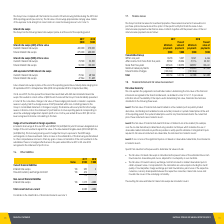According to National Storage Reit's financial document, What is the range of maturity dates of Future interest rate swaps in 2018? 24 September 2018 to 23 September 2026. The document states: "rom 23 September 2019 to 23 September 2026 (2018: 24 September 2018 to 23 September 2026). On 24 June 2019, the Group reset the interest rates associa..." Also, When did the Group reset the interest rates associated with AUD denominated interest rate swaps? According to the financial document, 24 June 2019. The relevant text states: "2018: 24 September 2018 to 23 September 2026). On 24 June 2019, the Group reset the interest rates associated with AUD denominated interest rate swaps. This resul..." Also, Where is the cumulative change in fair value of hedging instruments carried? in a separate reserve in equity (cash flow hedge reserve of NSPT presented within non-controlling interest in the Group’s consolidated statement of changes in equity).. The document states: "fair value of these hedging instruments is carried in a separate reserve in equity (cash flow hedge reserve of NSPT presented within non-controlling i..." Also, can you calculate: What is the change in Interest rate swaps (AUD) at face value for Current interest rate swaps from 2018 to 2019? Based on the calculation: 400,000-270,000, the result is 130000 (in thousands). This is based on the information: "Current interest rate swaps 400,000 270,000 Current interest rate swaps 400,000 270,000..." The key data points involved are: 270,000, 400,000. Also, can you calculate: What is the change in Interest rate swaps (AUD) at face value for Future interest rate swaps from 2018 to 2019? Based on the calculation: 275,000-400,000, the result is -125000 (in thousands). This is based on the information: "Future interest rate swaps 275,000 400,000 Future interest rate swaps 275,000 400,000..." The key data points involved are: 275,000, 400,000. Also, can you calculate: What is the change in Interest rate swaps (NZD) at face value for Current interest rate swaps from 2018 to 2019? Based on the calculation: 73,500-53,500, the result is 20000 (in thousands). This is based on the information: "Current interest rate swaps 73,500 53,500 Current interest rate swaps 73,500 53,500..." The key data points involved are: 53,500, 73,500. 